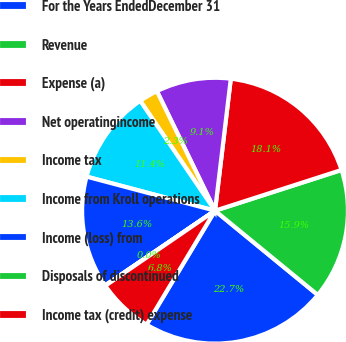<chart> <loc_0><loc_0><loc_500><loc_500><pie_chart><fcel>For the Years EndedDecember 31<fcel>Revenue<fcel>Expense (a)<fcel>Net operatingincome<fcel>Income tax<fcel>Income from Kroll operations<fcel>Income (loss) from<fcel>Disposals of discontinued<fcel>Income tax (credit) expense<nl><fcel>22.68%<fcel>15.89%<fcel>18.15%<fcel>9.1%<fcel>2.31%<fcel>11.36%<fcel>13.63%<fcel>0.05%<fcel>6.84%<nl></chart> 